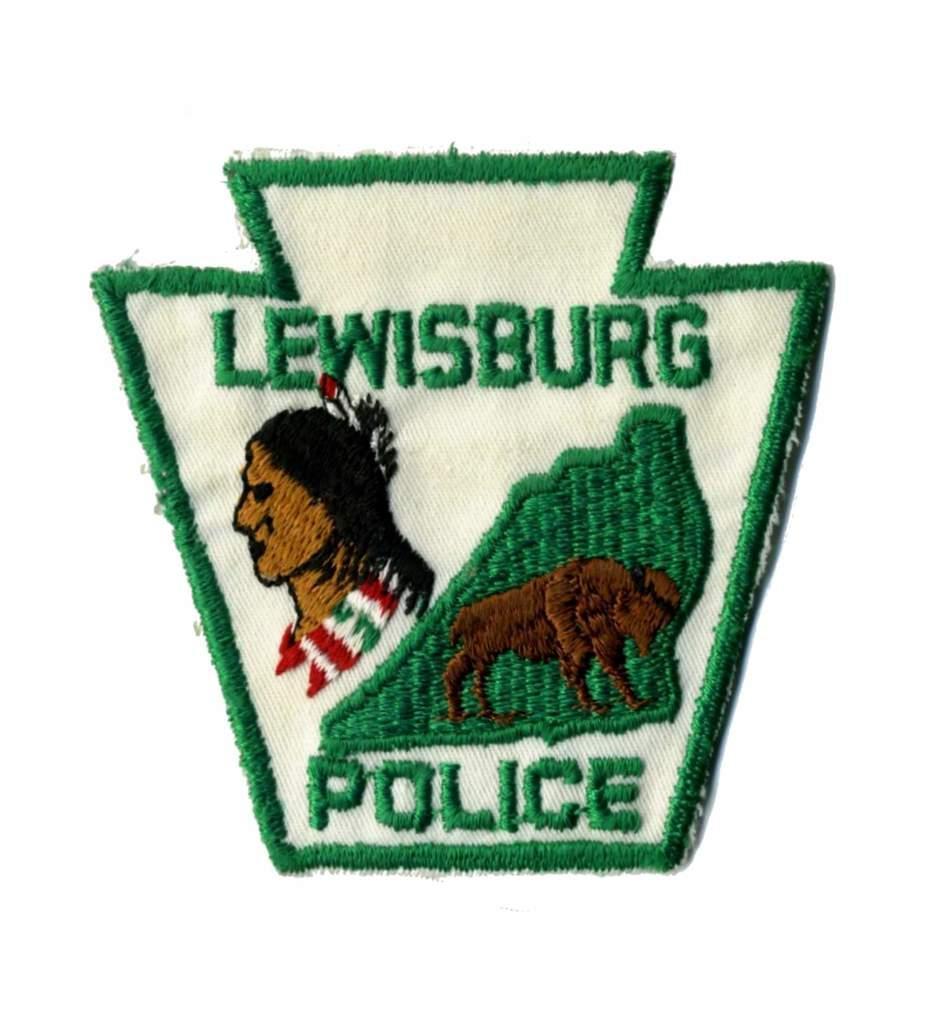Could you give a brief overview of what you see in this image? In the image there is a logo with images and text on it. And it is embroidery work on the cloth. 